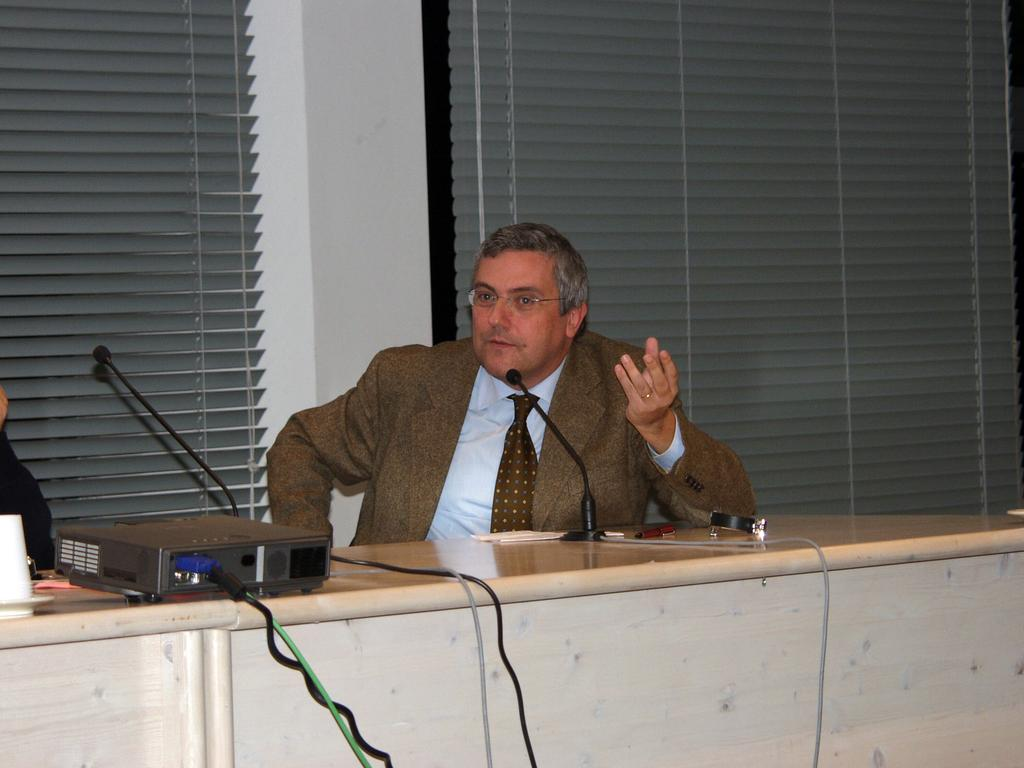Who is the main subject in the image? There is a man in the image. Where is the man located in the image? The man is sitting in the center of the image. What object is in front of the man on a table? There is a microphone in front of the man on a table. What can be seen in the background of the image? There are windows in the background of the image. What type of plants can be seen growing on the man's head in the image? There are no plants visible on the man's head in the image. How does the man's temper affect the lighting in the image? The man's temper does not affect the lighting in the image; the lighting is consistent throughout the scene. 